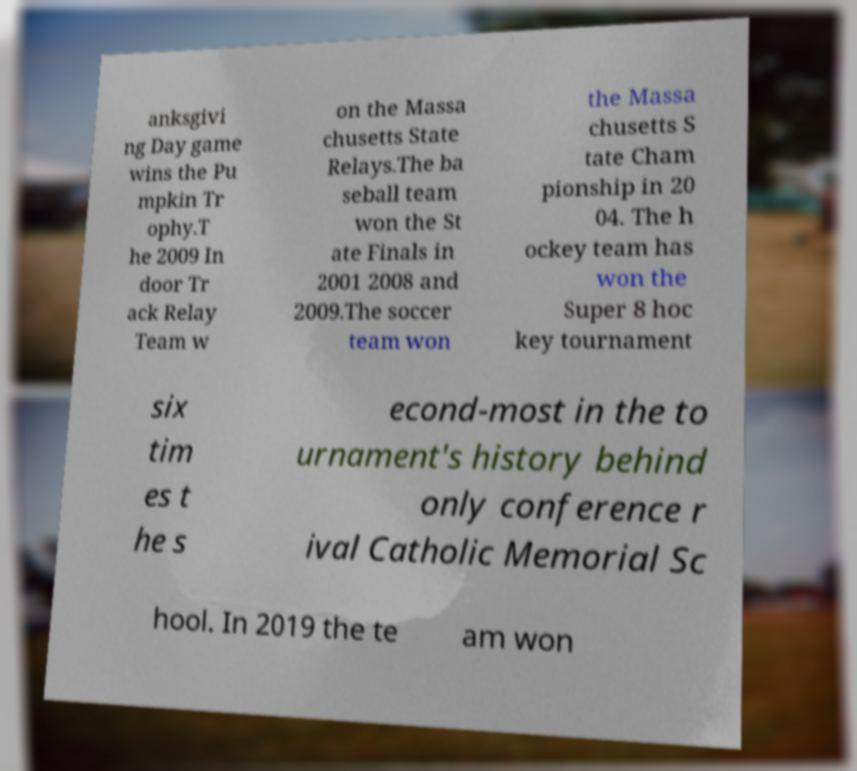Can you accurately transcribe the text from the provided image for me? anksgivi ng Day game wins the Pu mpkin Tr ophy.T he 2009 In door Tr ack Relay Team w on the Massa chusetts State Relays.The ba seball team won the St ate Finals in 2001 2008 and 2009.The soccer team won the Massa chusetts S tate Cham pionship in 20 04. The h ockey team has won the Super 8 hoc key tournament six tim es t he s econd-most in the to urnament's history behind only conference r ival Catholic Memorial Sc hool. In 2019 the te am won 